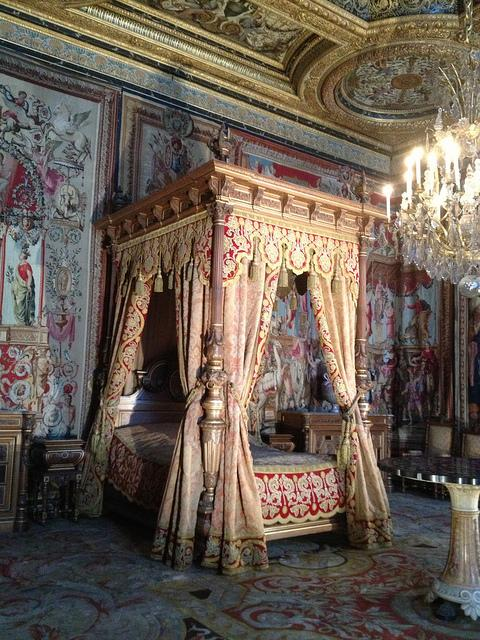What is needed to light the candles on the chandeliers?

Choices:
A) air
B) minerals
C) fire
D) water fire 